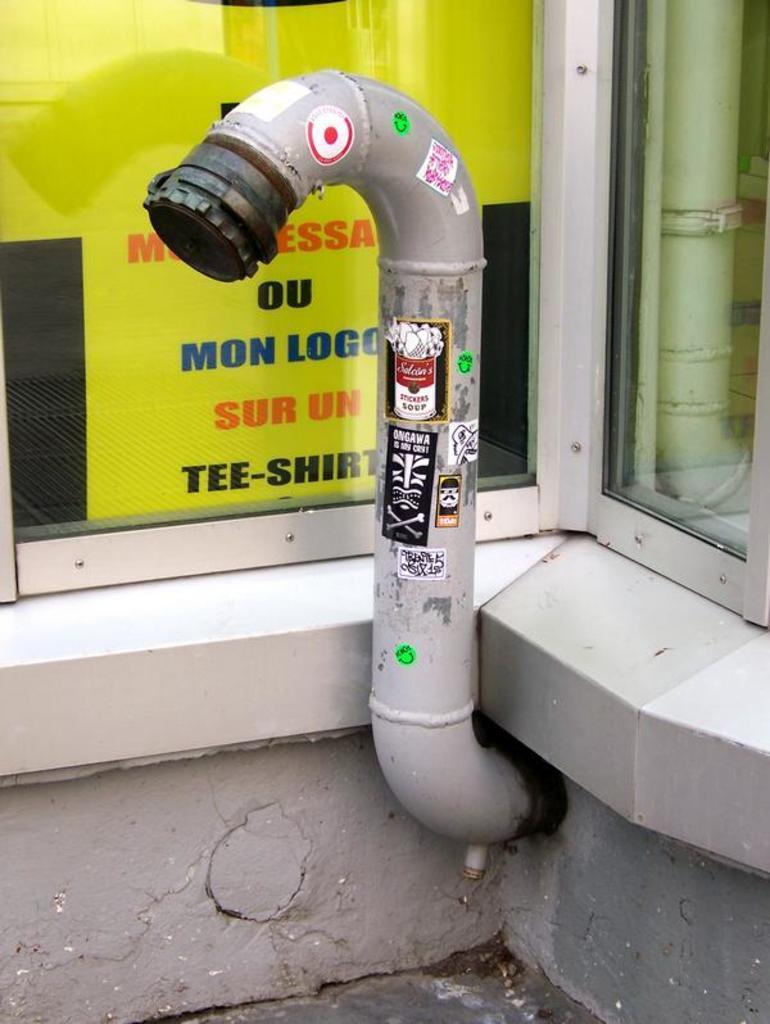Please provide a concise description of this image. In the image there is a pipe with few stickers on it. Behind the pipe there is a glass window. Behind the glass there are posters with some text on it. On the right side of the image there is a glass with a reflection of pipe. 